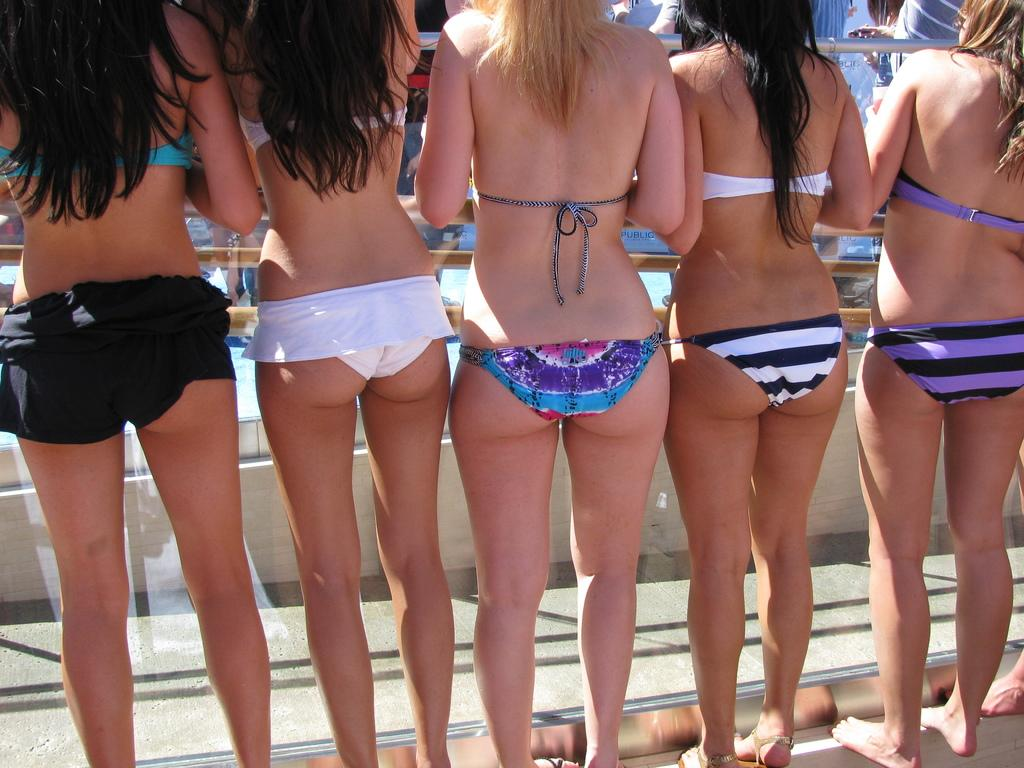What is the main subject of the image? The main subject of the image is women. What are the women doing in the image? The women are standing in the image. What type of clothing are the women wearing? The women are wearing bikinis in the image. Is there any blood visible on the women in the image? There is no blood visible on the women in the image. How many toes can be seen on the women in the image? The number of toes on the women cannot be determined from the image. 